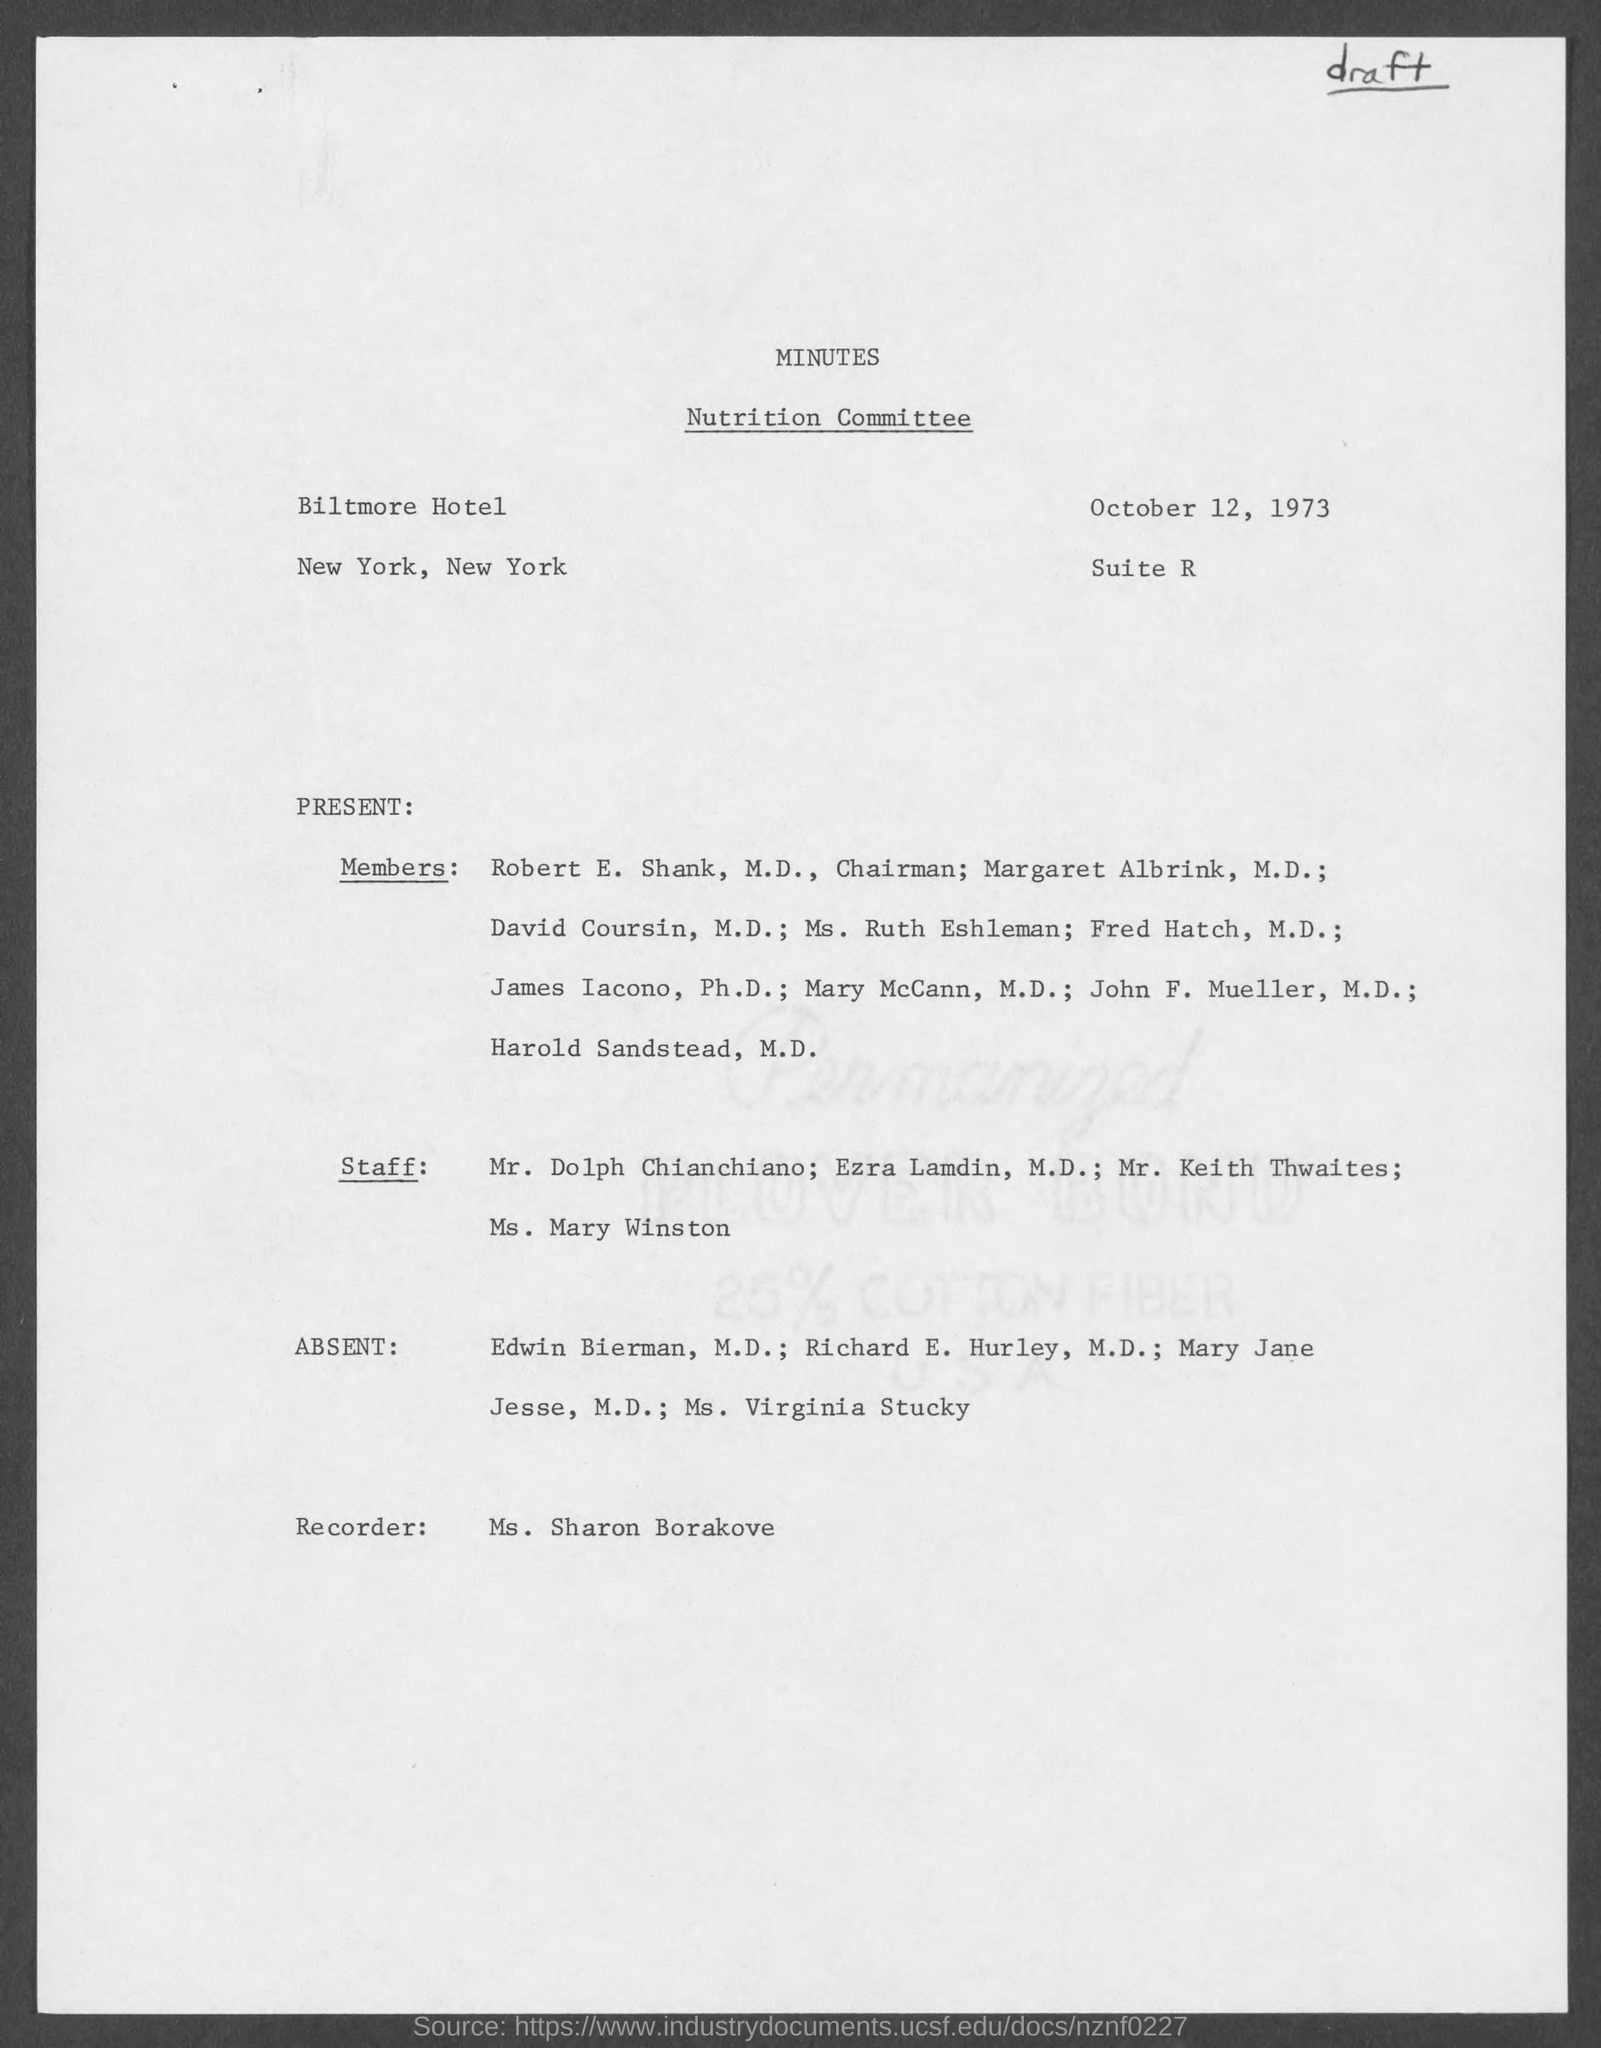Specify some key components in this picture. The date of October 12, 1973 was when the minutes were taken. Ms. Sharon Borakove is the recorder of the Nutrition Committee. The Chairman of the Nutrition Committee is Robert E. Shank. The Nutrition Committee held its meeting at the Biltmore Hotel. I would like to declare that the title of the committee is the Nutrition Committee. 